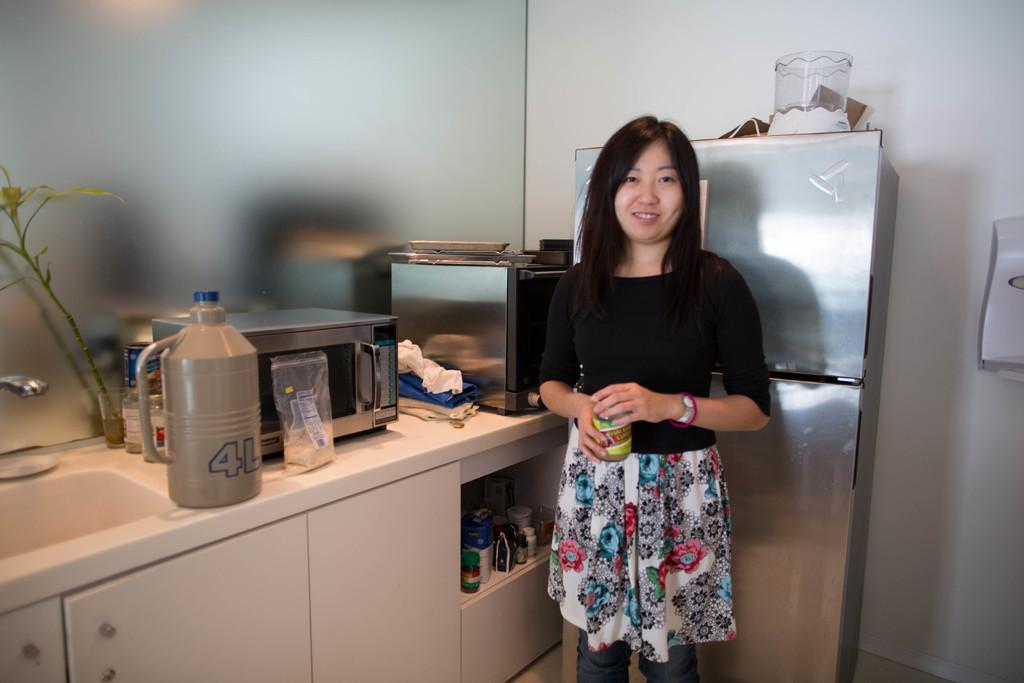<image>
Render a clear and concise summary of the photo. Gray and blue 4L can on a counter 